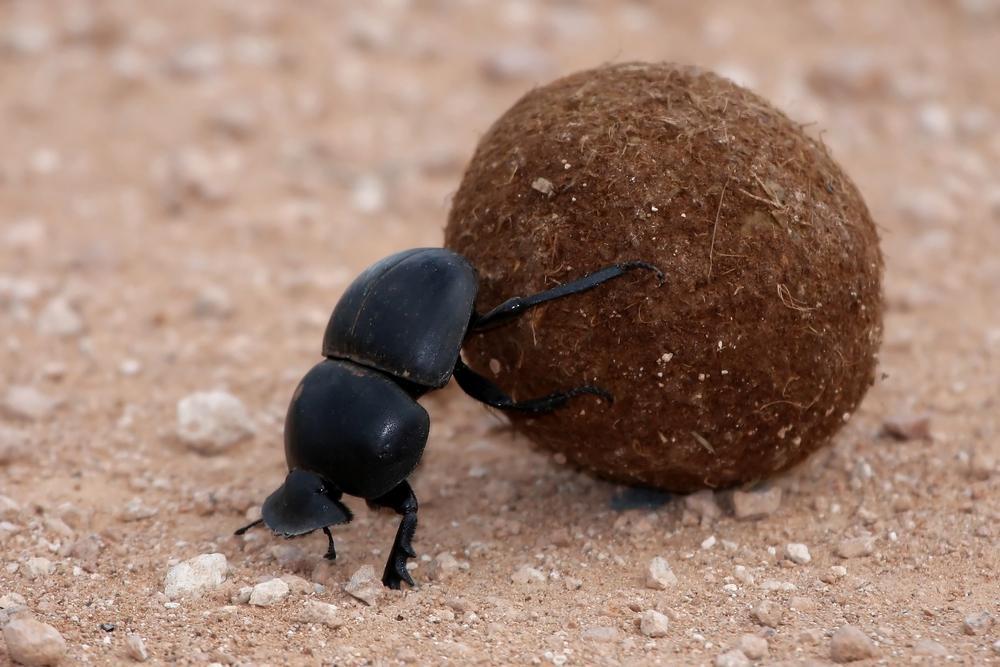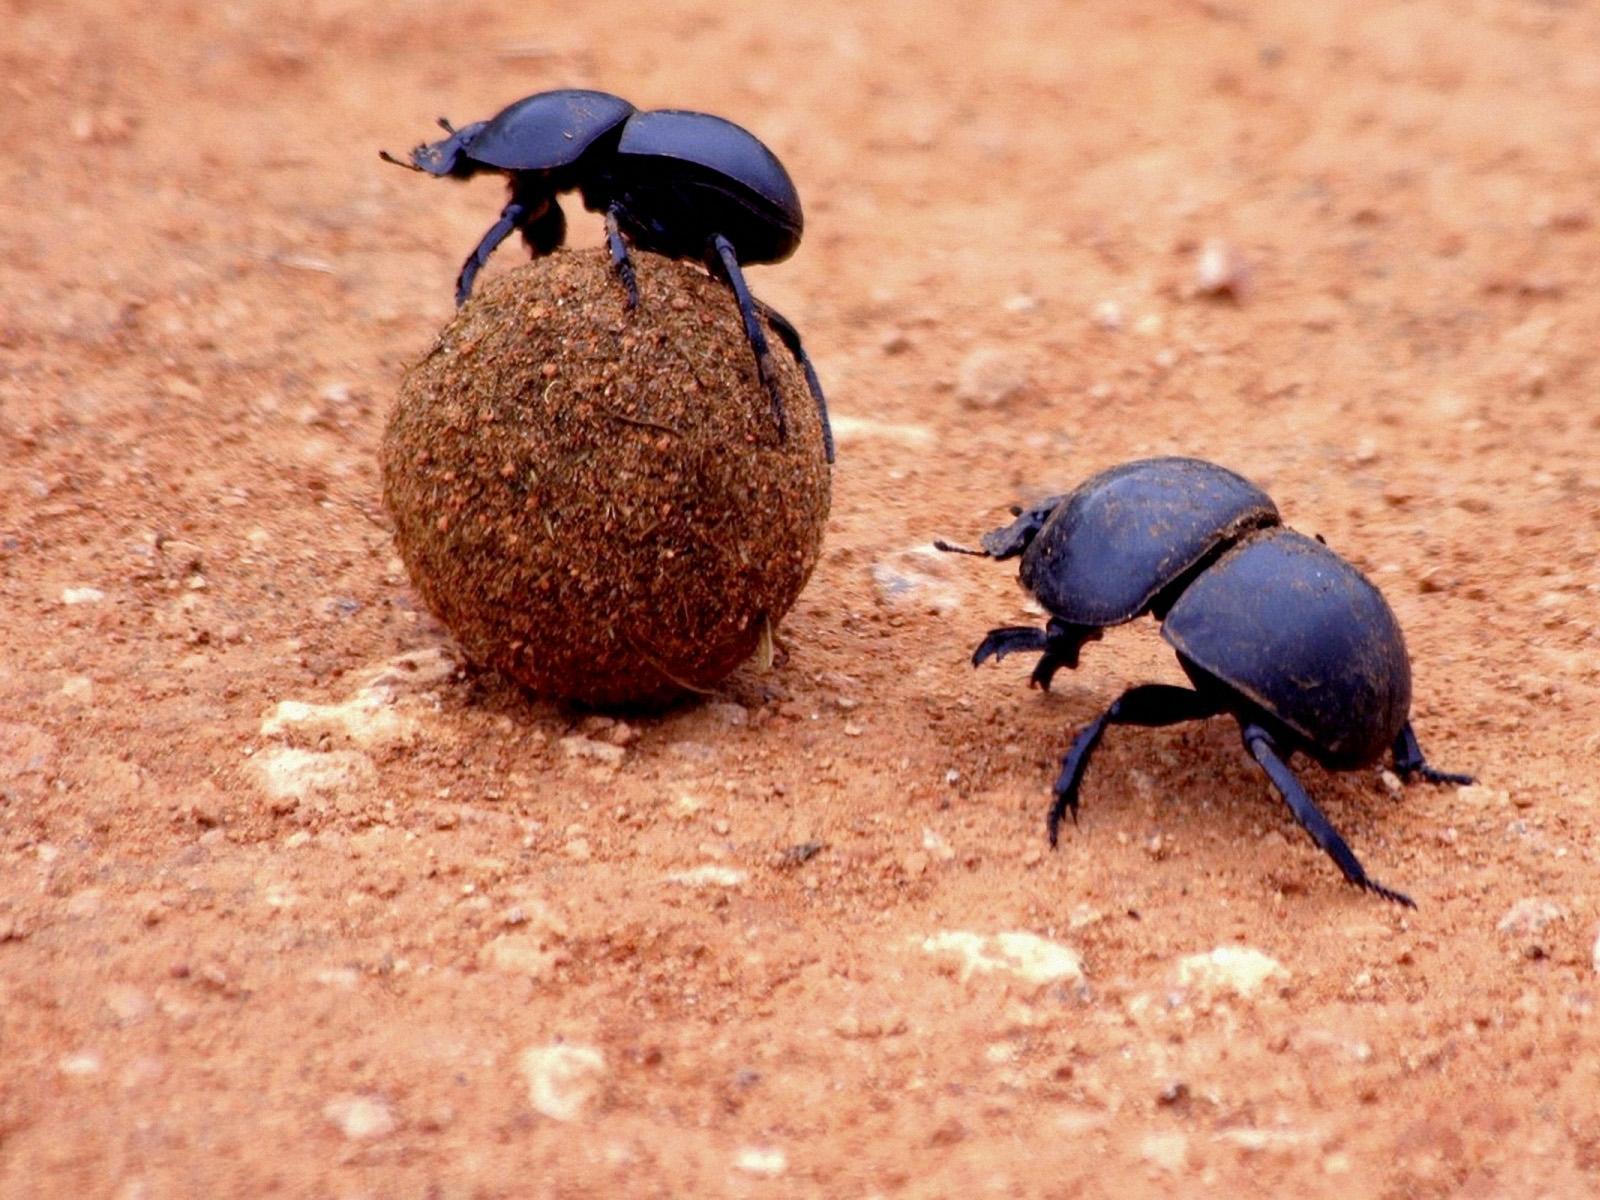The first image is the image on the left, the second image is the image on the right. Analyze the images presented: Is the assertion "An image includes one dung ball and two beetles." valid? Answer yes or no. Yes. 